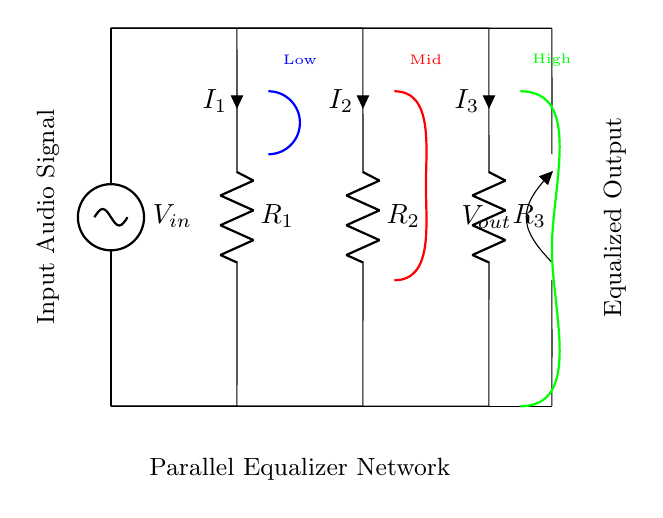What is the input voltage in the circuit? The input voltage is denoted as V_in at the top of the circuit diagram where the input audio signal is applied.
Answer: V_in How many resistors are present in the circuit? There are three resistors labeled R_1, R_2, and R_3 shown in parallel configuration in the diagram.
Answer: 3 What type of circuit is this? The circuit is a parallel circuit as indicated by the configuration where multiple branches are connected across the same voltage source.
Answer: Parallel What is the output voltage labeled as in the diagram? The output voltage is labeled as V_out, which represents the voltage across the output connections below the parallel resistors.
Answer: V_out What do the colors of the frequency response curves represent? The colors blue, red, and green denote low, mid, and high frequency responses, respectively, highlighting their equalization in the audio signal.
Answer: Low, Mid, High What is the total current flowing through the circuit? To determine the total current, we sum the currents I_1, I_2, and I_3 flowing through their respective resistors in the parallel branches.
Answer: I_1 + I_2 + I_3 How does the circuit ensure equalization of audio signals? The parallel arrangement allows different frequency components to be adjusted through their respective resistors, enabling the equalization effect across the output.
Answer: Through parallel resistor values 